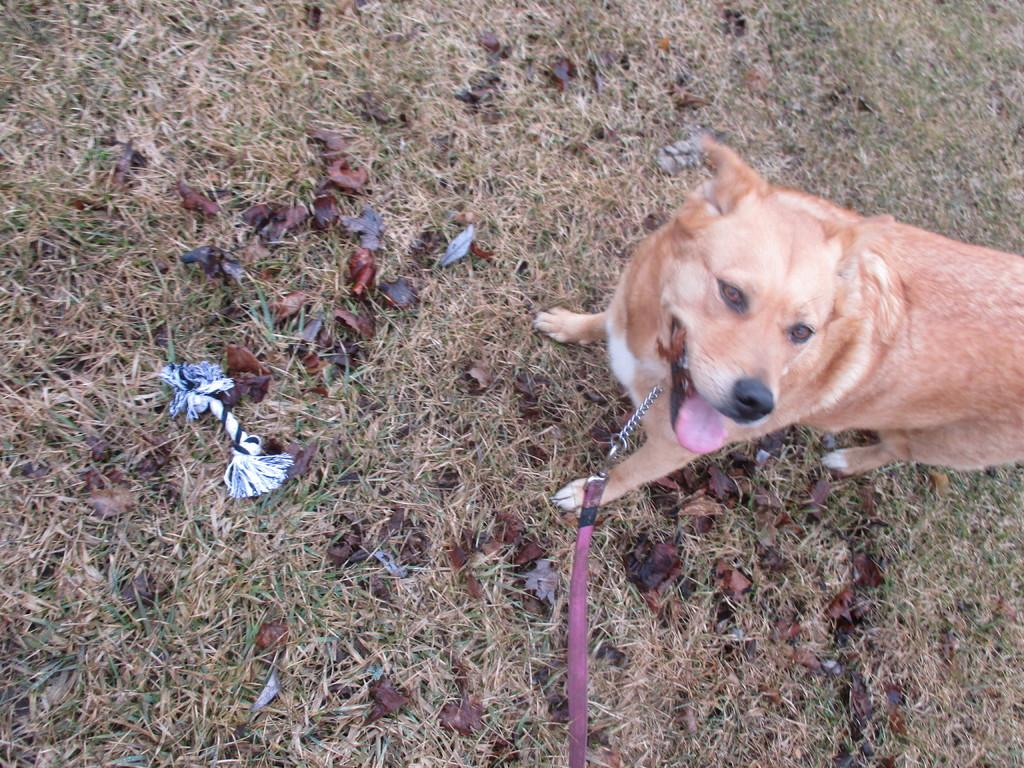What type of animal is in the image? There is a dog in the image. What is the dog's position in relation to the ground? The dog is standing on the ground. Is there anything attached to the dog's neck? Yes, there is a chain tied to the dog's neck. What type of vegetation is present on the ground? Dry grass is present on the ground. What type of brick is used to build the garden in the image? There is no garden present in the image, and therefore no bricks can be observed. 